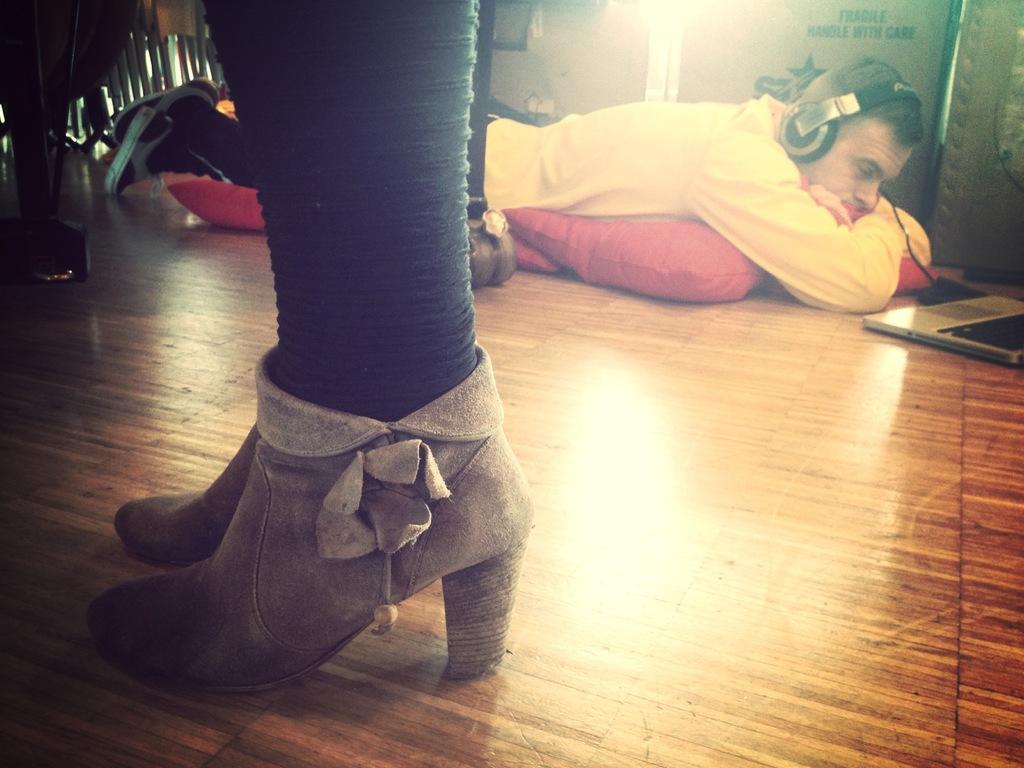Describe this image in one or two sentences. In this picture, we can see two persons and we can see the floor and some objects on the floor like pillows, laptop and we can see some objects in the top left corner and we can see the wall with some text on it. 